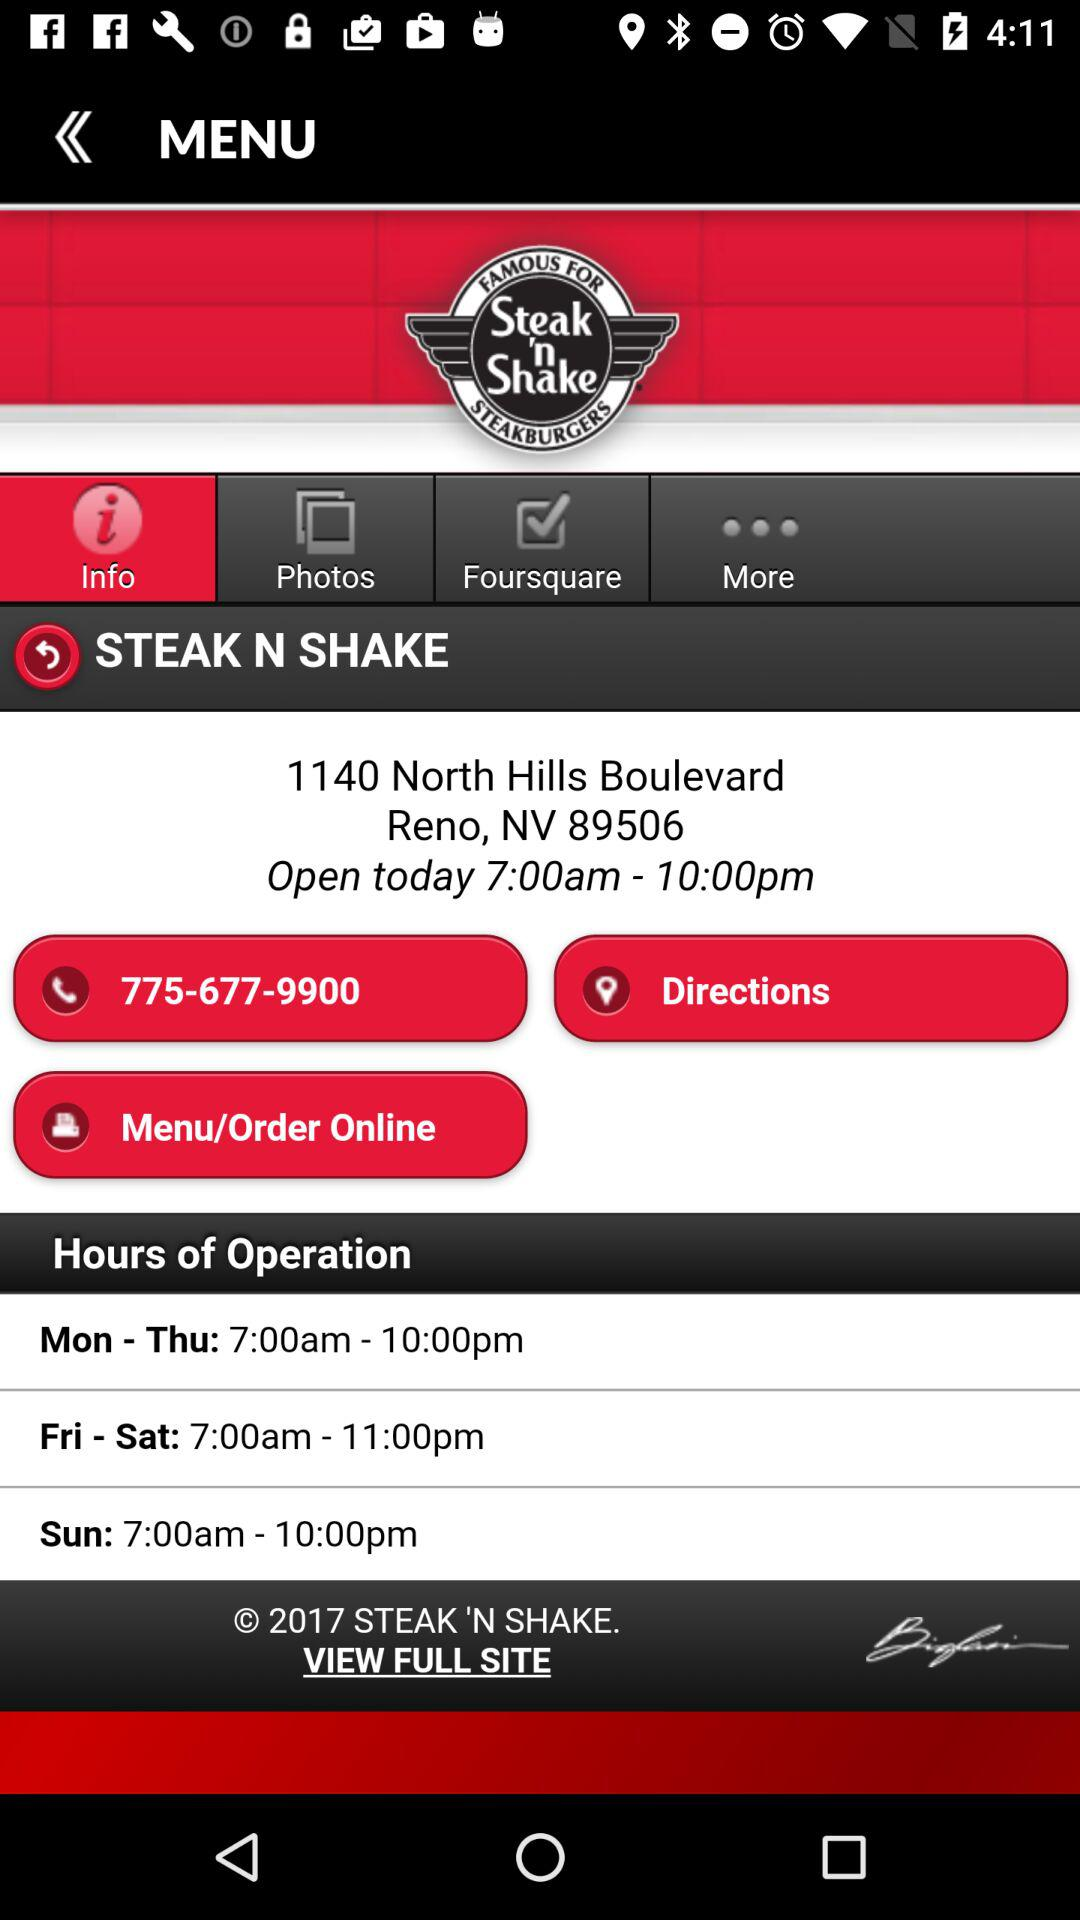What is the time of opening? The time of opening is 7 a.m. 